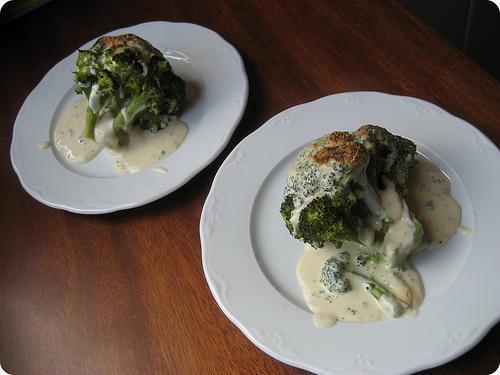How many tables or counters are in the picture?
Give a very brief answer. 1. 